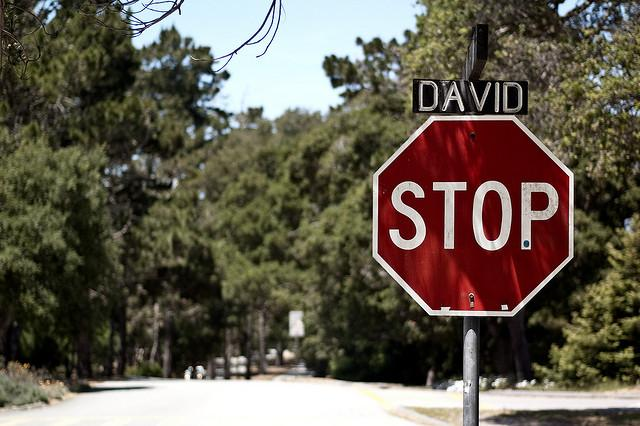What is the name of the street parallel to the stop sign? Please explain your reasoning. david. The name is on the sign 